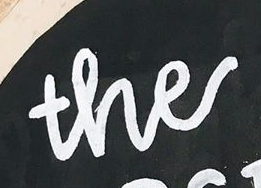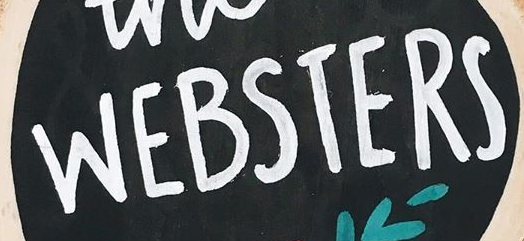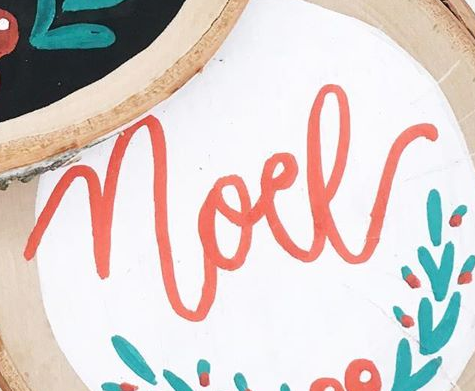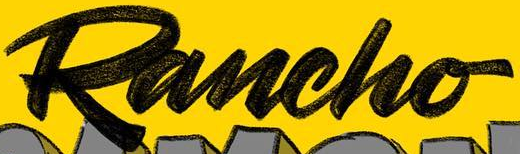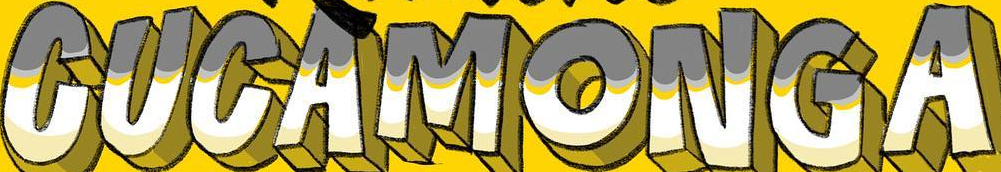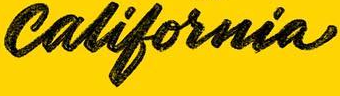What text is displayed in these images sequentially, separated by a semicolon? the; WEBSTERS; noel; Rancho; CUCAMONGA; california 